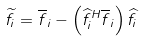Convert formula to latex. <formula><loc_0><loc_0><loc_500><loc_500>\widetilde { f } _ { i } = \overline { f } _ { i } - \left ( \widehat { f } _ { i } ^ { H } \overline { f } _ { i } \right ) \widehat { f } _ { i }</formula> 